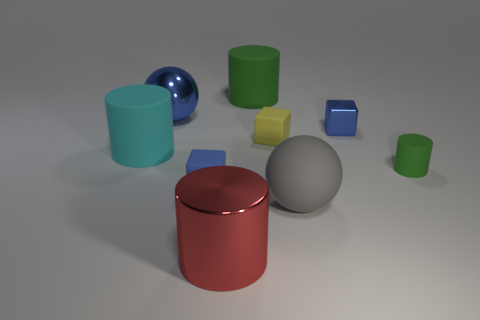Subtract all matte cubes. How many cubes are left? 1 Subtract all blue balls. How many green cylinders are left? 2 Subtract all red cylinders. How many cylinders are left? 3 Subtract 1 cylinders. How many cylinders are left? 3 Subtract all gray cylinders. Subtract all brown spheres. How many cylinders are left? 4 Subtract all spheres. How many objects are left? 7 Subtract all big cyan matte cylinders. Subtract all large red cylinders. How many objects are left? 7 Add 1 big rubber objects. How many big rubber objects are left? 4 Add 9 matte balls. How many matte balls exist? 10 Subtract 0 purple blocks. How many objects are left? 9 